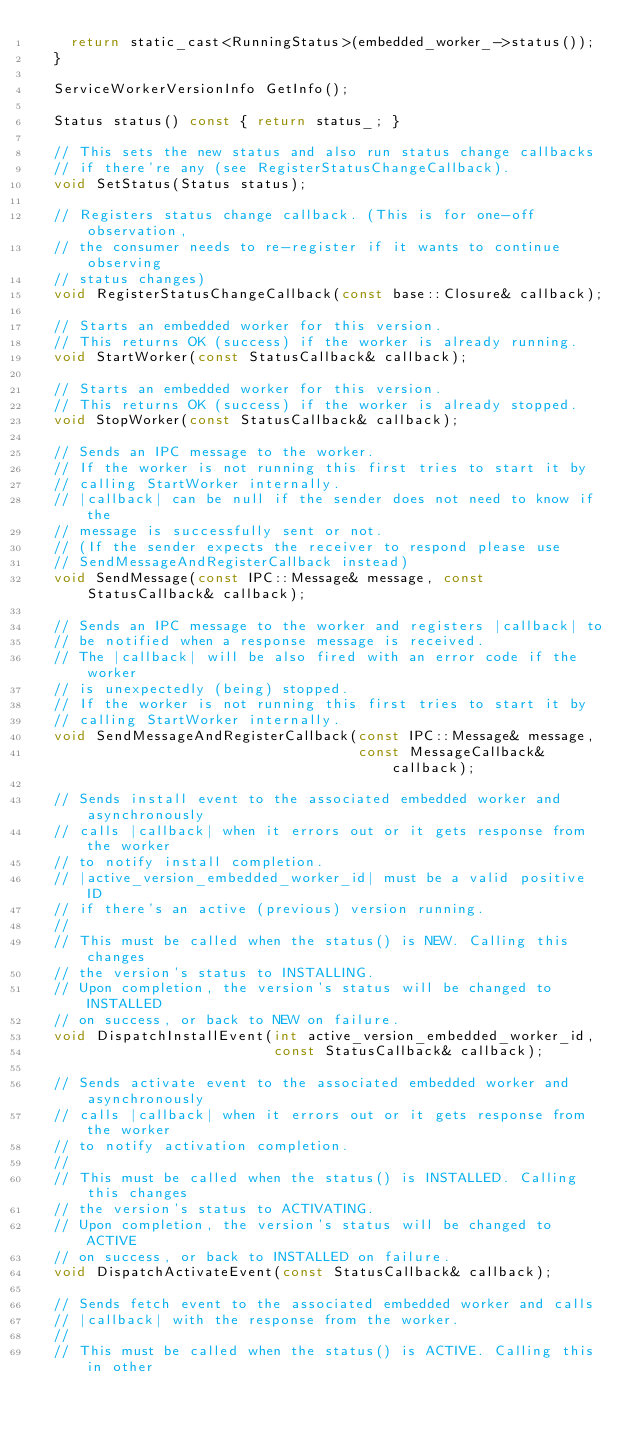Convert code to text. <code><loc_0><loc_0><loc_500><loc_500><_C_>    return static_cast<RunningStatus>(embedded_worker_->status());
  }

  ServiceWorkerVersionInfo GetInfo();

  Status status() const { return status_; }

  // This sets the new status and also run status change callbacks
  // if there're any (see RegisterStatusChangeCallback).
  void SetStatus(Status status);

  // Registers status change callback. (This is for one-off observation,
  // the consumer needs to re-register if it wants to continue observing
  // status changes)
  void RegisterStatusChangeCallback(const base::Closure& callback);

  // Starts an embedded worker for this version.
  // This returns OK (success) if the worker is already running.
  void StartWorker(const StatusCallback& callback);

  // Starts an embedded worker for this version.
  // This returns OK (success) if the worker is already stopped.
  void StopWorker(const StatusCallback& callback);

  // Sends an IPC message to the worker.
  // If the worker is not running this first tries to start it by
  // calling StartWorker internally.
  // |callback| can be null if the sender does not need to know if the
  // message is successfully sent or not.
  // (If the sender expects the receiver to respond please use
  // SendMessageAndRegisterCallback instead)
  void SendMessage(const IPC::Message& message, const StatusCallback& callback);

  // Sends an IPC message to the worker and registers |callback| to
  // be notified when a response message is received.
  // The |callback| will be also fired with an error code if the worker
  // is unexpectedly (being) stopped.
  // If the worker is not running this first tries to start it by
  // calling StartWorker internally.
  void SendMessageAndRegisterCallback(const IPC::Message& message,
                                      const MessageCallback& callback);

  // Sends install event to the associated embedded worker and asynchronously
  // calls |callback| when it errors out or it gets response from the worker
  // to notify install completion.
  // |active_version_embedded_worker_id| must be a valid positive ID
  // if there's an active (previous) version running.
  //
  // This must be called when the status() is NEW. Calling this changes
  // the version's status to INSTALLING.
  // Upon completion, the version's status will be changed to INSTALLED
  // on success, or back to NEW on failure.
  void DispatchInstallEvent(int active_version_embedded_worker_id,
                            const StatusCallback& callback);

  // Sends activate event to the associated embedded worker and asynchronously
  // calls |callback| when it errors out or it gets response from the worker
  // to notify activation completion.
  //
  // This must be called when the status() is INSTALLED. Calling this changes
  // the version's status to ACTIVATING.
  // Upon completion, the version's status will be changed to ACTIVE
  // on success, or back to INSTALLED on failure.
  void DispatchActivateEvent(const StatusCallback& callback);

  // Sends fetch event to the associated embedded worker and calls
  // |callback| with the response from the worker.
  //
  // This must be called when the status() is ACTIVE. Calling this in other</code> 